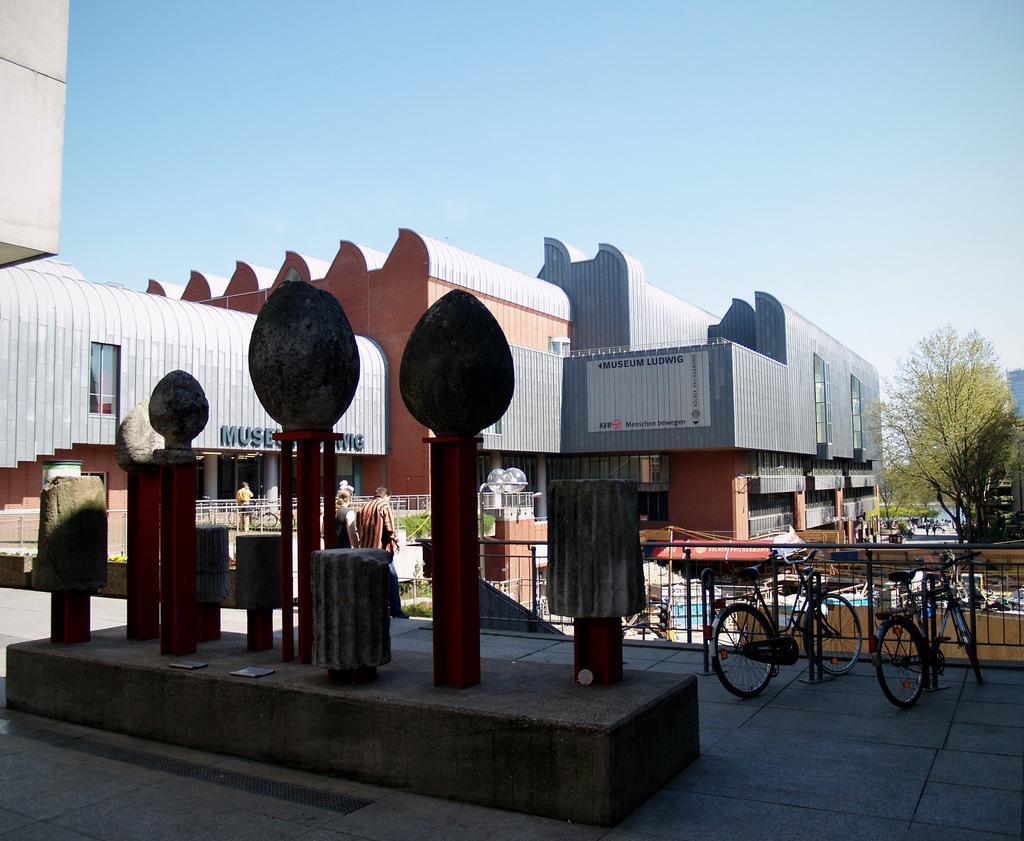How would you summarize this image in a sentence or two? In this image there are sculptures on the poles. Behind the sculptures there are people standing. There are cycles parked on the floor. In front of the cycles there is a railing. Behind the railing there are buildings. To the right there are trees. At the top there is the sky. 